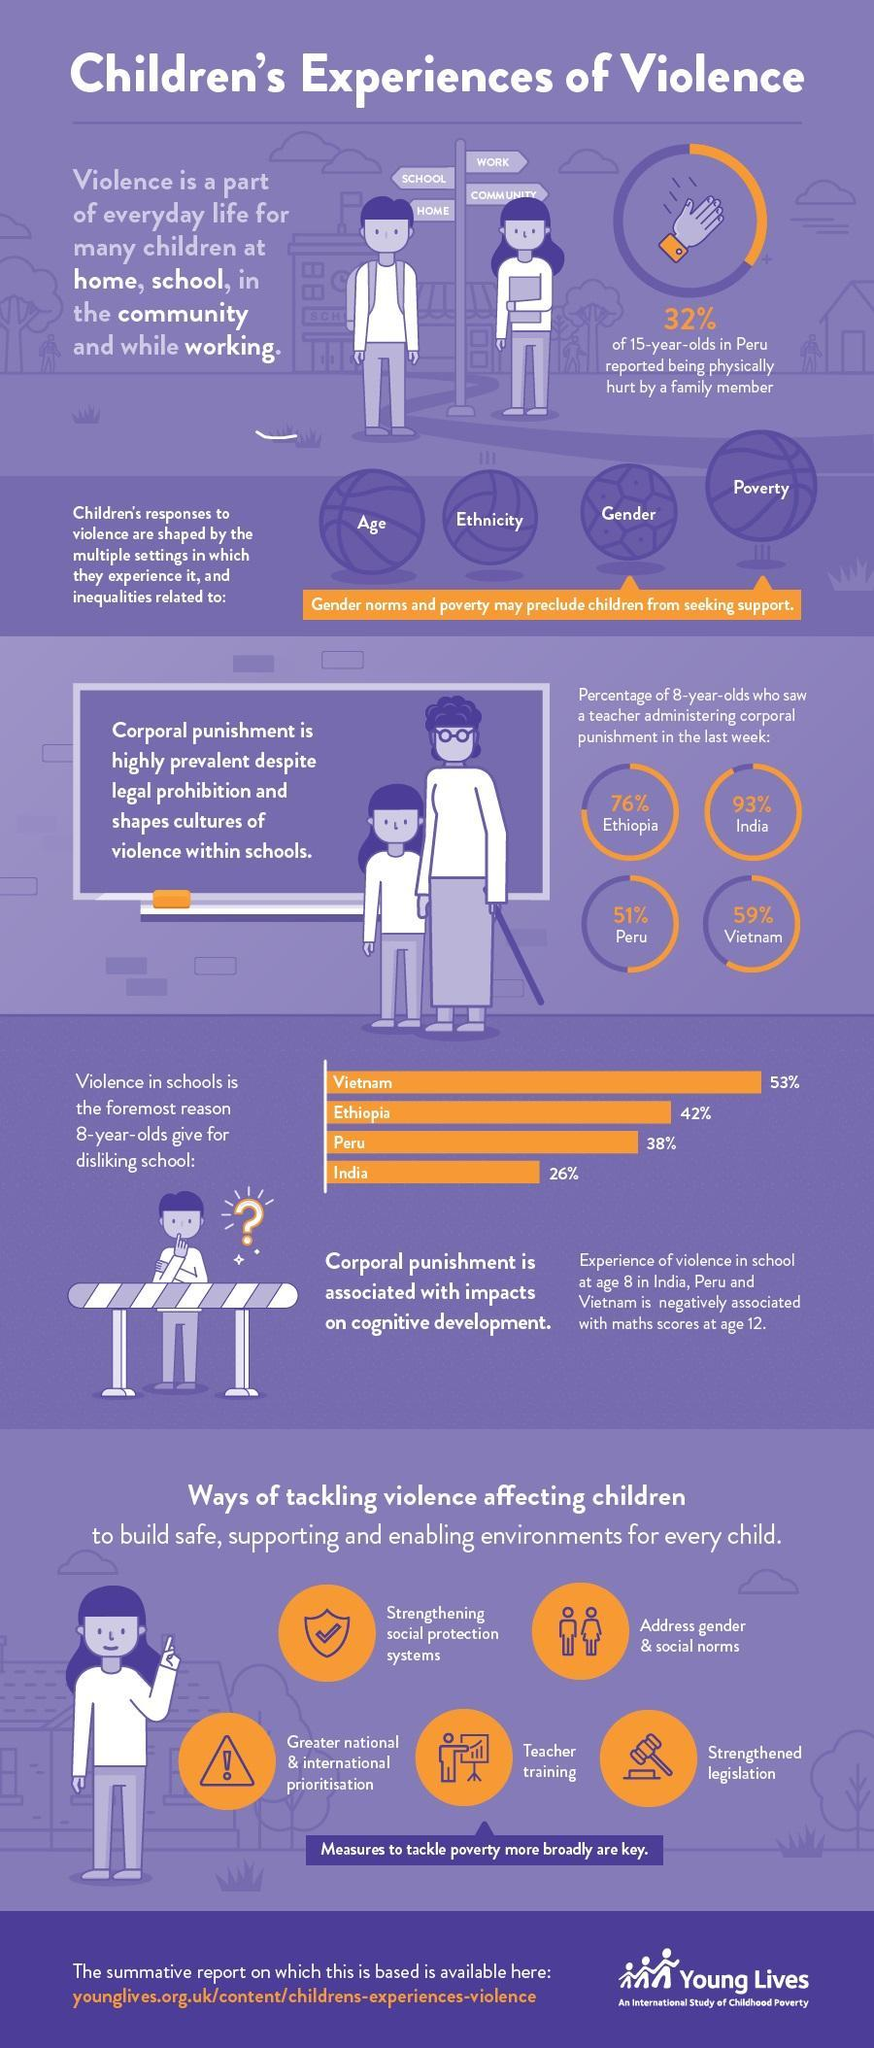What percentage of 8-year-olds in Vietnam saw a teacher administering corporal punishment last week?
Answer the question with a short phrase. 59% What percentage of 15-years-old in Peru reported not being physically hurt by a family member? 68% What percentage of 8-year-olds in India saw a teacher administering corporal punishment last week? 93% 